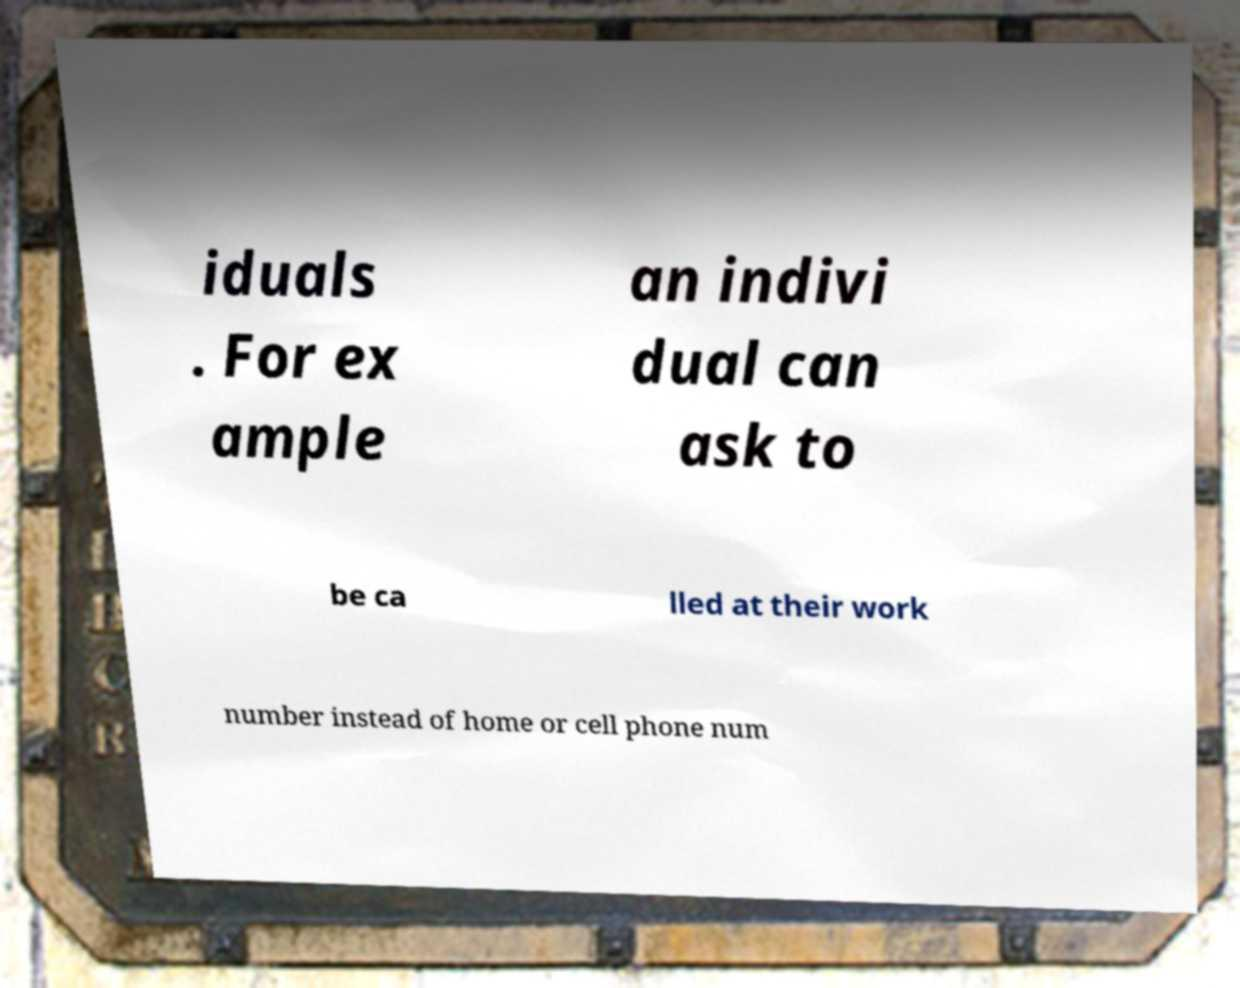Please read and relay the text visible in this image. What does it say? iduals . For ex ample an indivi dual can ask to be ca lled at their work number instead of home or cell phone num 